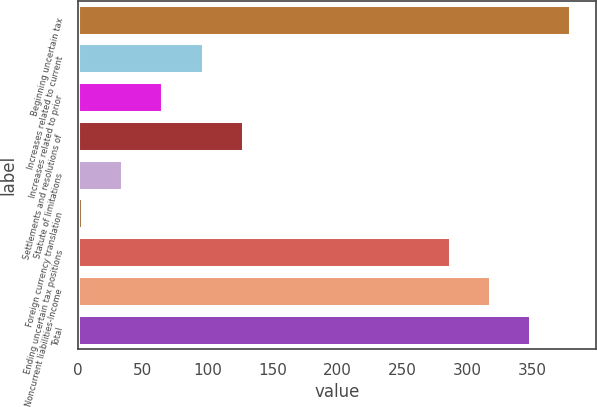Convert chart. <chart><loc_0><loc_0><loc_500><loc_500><bar_chart><fcel>Beginning uncertain tax<fcel>Increases related to current<fcel>Increases related to prior<fcel>Settlements and resolutions of<fcel>Statute of limitations<fcel>Foreign currency translation<fcel>Ending uncertain tax positions<fcel>Noncurrent liabilities-Income<fcel>Total<nl><fcel>379.7<fcel>96.7<fcel>65.8<fcel>127.6<fcel>34.9<fcel>4<fcel>287<fcel>317.9<fcel>348.8<nl></chart> 